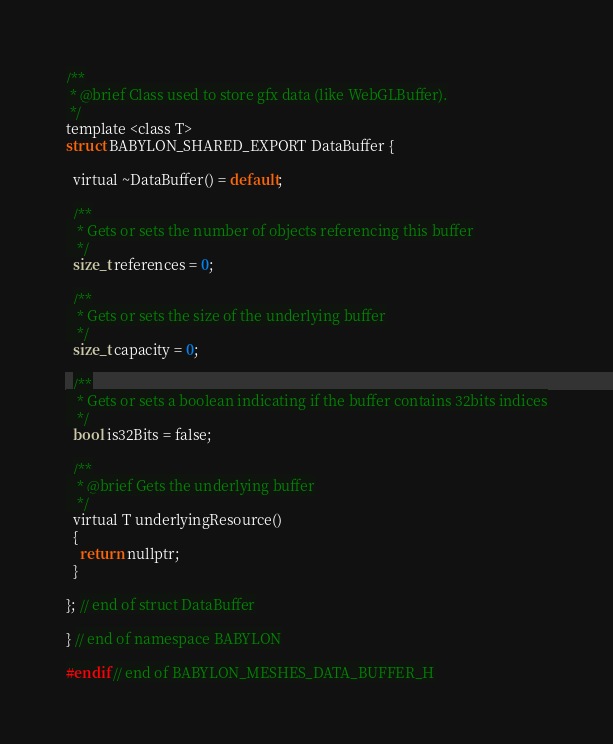Convert code to text. <code><loc_0><loc_0><loc_500><loc_500><_C_>/**
 * @brief Class used to store gfx data (like WebGLBuffer).
 */
template <class T>
struct BABYLON_SHARED_EXPORT DataBuffer {

  virtual ~DataBuffer() = default;

  /**
   * Gets or sets the number of objects referencing this buffer
   */
  size_t references = 0;

  /**
   * Gets or sets the size of the underlying buffer
   */
  size_t capacity = 0;

  /**
   * Gets or sets a boolean indicating if the buffer contains 32bits indices
   */
  bool is32Bits = false;

  /**
   * @brief Gets the underlying buffer
   */
  virtual T underlyingResource()
  {
    return nullptr;
  }

}; // end of struct DataBuffer

} // end of namespace BABYLON

#endif // end of BABYLON_MESHES_DATA_BUFFER_H
</code> 